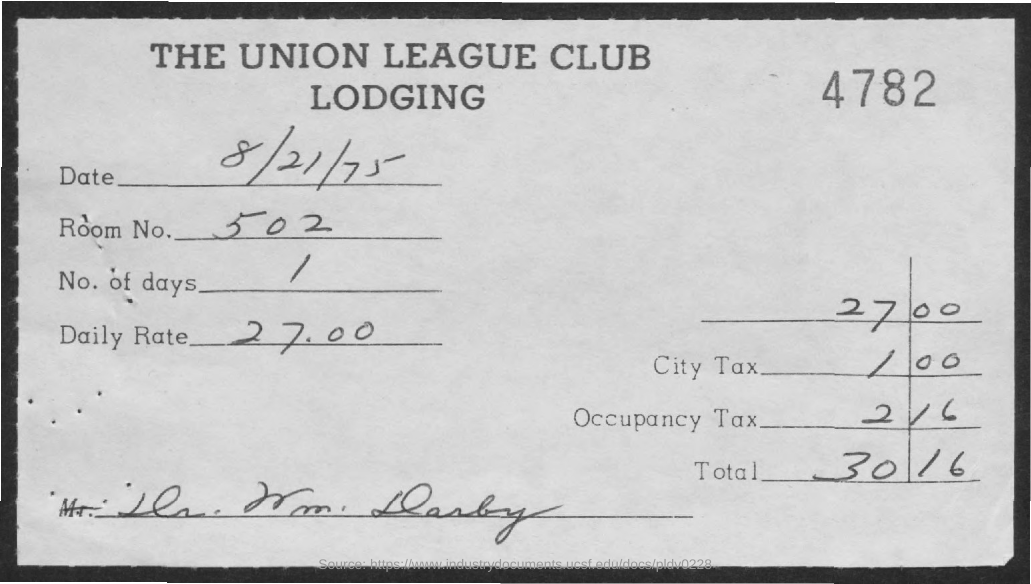Outline some significant characteristics in this image. The Room No. mentioned in the document is 502. The document mentions a daily rate of 27.00... The document mentions a date of August 21, 1975. The lodging mentioned in the document is named THE UNION LEAGUE CLUB LODGING. The number of days provided in the document is 1.. 